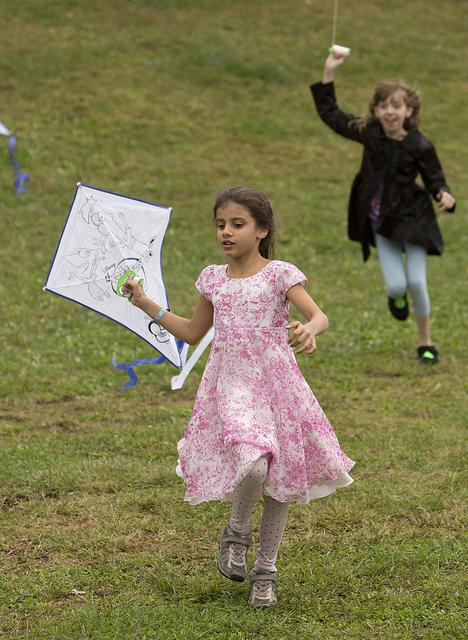Are these two people dressed nicely?
Be succinct. Yes. Which girl is wearing a pink dress?
Answer briefly. Front. What kind of shoes is the girl wearing?
Answer briefly. Sneakers. 